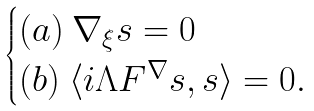Convert formula to latex. <formula><loc_0><loc_0><loc_500><loc_500>\begin{cases} ( a ) \ \nabla _ { \xi } s = 0 \\ ( b ) \ \langle i \Lambda F ^ { \nabla } s , s \rangle = 0 . \end{cases}</formula> 